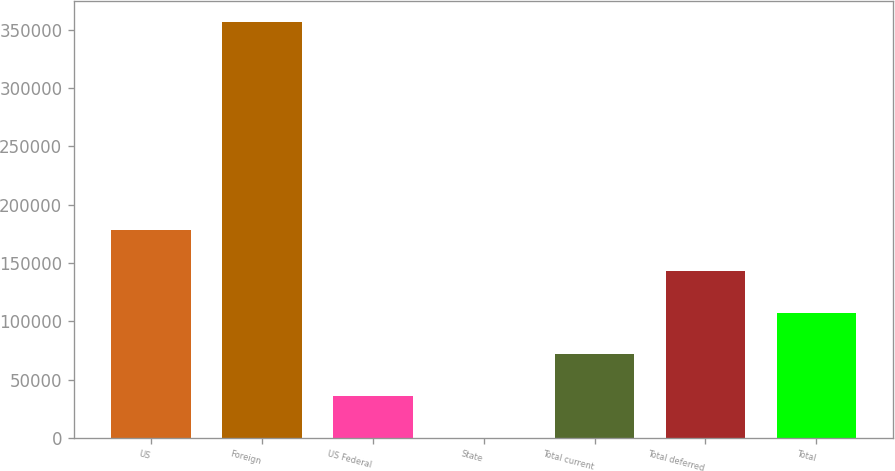Convert chart to OTSL. <chart><loc_0><loc_0><loc_500><loc_500><bar_chart><fcel>US<fcel>Foreign<fcel>US Federal<fcel>State<fcel>Total current<fcel>Total deferred<fcel>Total<nl><fcel>178498<fcel>356808<fcel>35850<fcel>188<fcel>71512<fcel>142836<fcel>107174<nl></chart> 